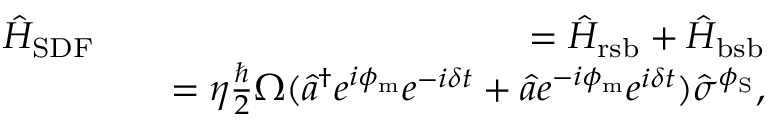<formula> <loc_0><loc_0><loc_500><loc_500>\begin{array} { r l r } { \hat { H } _ { S D F } } & { = \hat { H } _ { r s b } + \hat { H } _ { b s b } } \\ & { = \eta \frac { } { 2 } \Omega ( \hat { a } ^ { \dagger } e ^ { i \phi _ { m } } e ^ { - i \delta t } + \hat { a } e ^ { - i \phi _ { m } } e ^ { i \delta t } ) \hat { \sigma } ^ { \phi _ { S } } , } \end{array}</formula> 